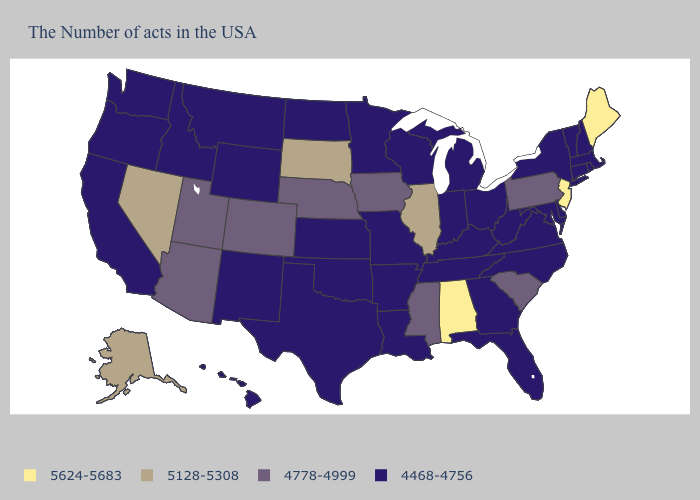Name the states that have a value in the range 5128-5308?
Concise answer only. Illinois, South Dakota, Nevada, Alaska. Does Montana have the same value as Maine?
Quick response, please. No. Name the states that have a value in the range 4468-4756?
Give a very brief answer. Massachusetts, Rhode Island, New Hampshire, Vermont, Connecticut, New York, Delaware, Maryland, Virginia, North Carolina, West Virginia, Ohio, Florida, Georgia, Michigan, Kentucky, Indiana, Tennessee, Wisconsin, Louisiana, Missouri, Arkansas, Minnesota, Kansas, Oklahoma, Texas, North Dakota, Wyoming, New Mexico, Montana, Idaho, California, Washington, Oregon, Hawaii. What is the value of New York?
Short answer required. 4468-4756. Is the legend a continuous bar?
Keep it brief. No. Name the states that have a value in the range 5624-5683?
Be succinct. Maine, New Jersey, Alabama. Does Alaska have the highest value in the USA?
Write a very short answer. No. What is the value of Michigan?
Give a very brief answer. 4468-4756. What is the value of Missouri?
Short answer required. 4468-4756. Does Alabama have a higher value than Oklahoma?
Quick response, please. Yes. Which states have the lowest value in the USA?
Be succinct. Massachusetts, Rhode Island, New Hampshire, Vermont, Connecticut, New York, Delaware, Maryland, Virginia, North Carolina, West Virginia, Ohio, Florida, Georgia, Michigan, Kentucky, Indiana, Tennessee, Wisconsin, Louisiana, Missouri, Arkansas, Minnesota, Kansas, Oklahoma, Texas, North Dakota, Wyoming, New Mexico, Montana, Idaho, California, Washington, Oregon, Hawaii. Among the states that border Arkansas , which have the highest value?
Give a very brief answer. Mississippi. What is the lowest value in states that border Massachusetts?
Short answer required. 4468-4756. Does the first symbol in the legend represent the smallest category?
Short answer required. No. Which states have the highest value in the USA?
Answer briefly. Maine, New Jersey, Alabama. 